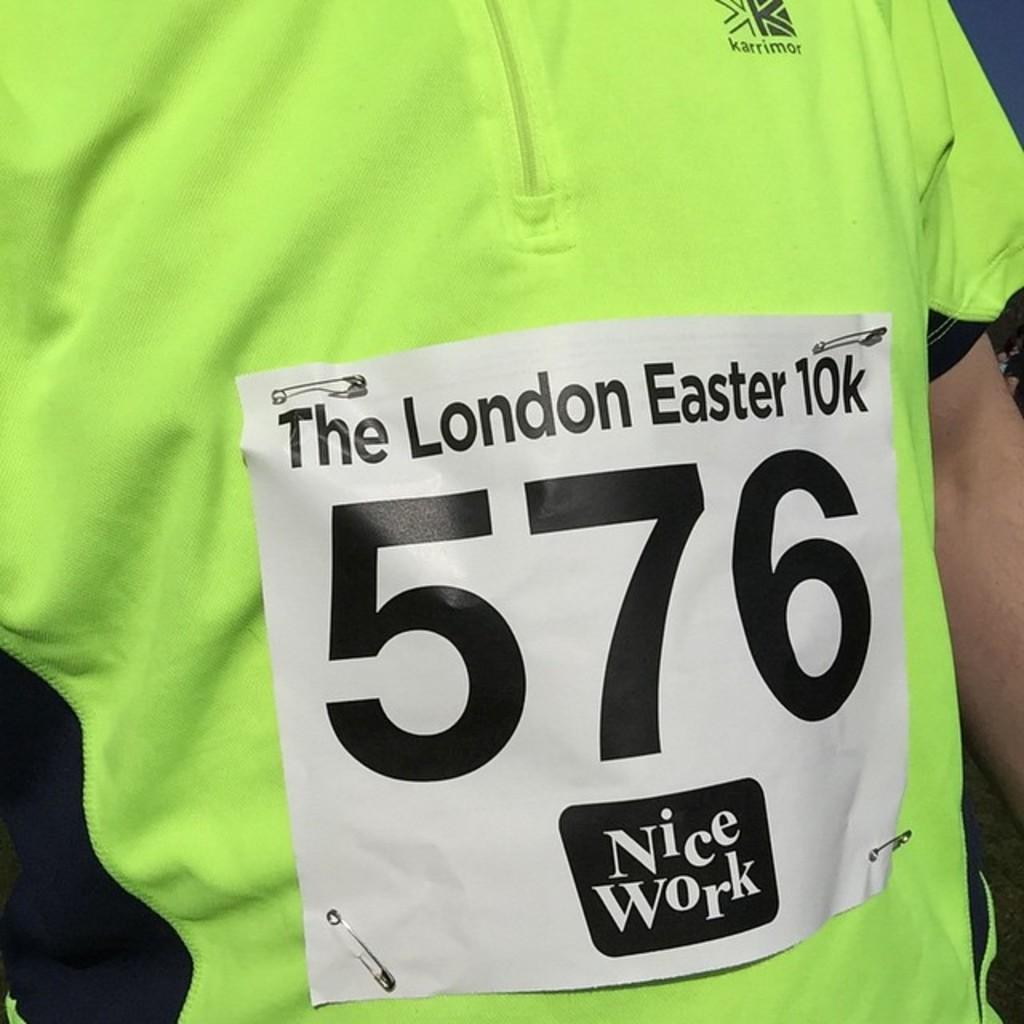Provide a one-sentence caption for the provided image. A yellow shirt has runner number 576 of The London Easter 10K pinned to it. 